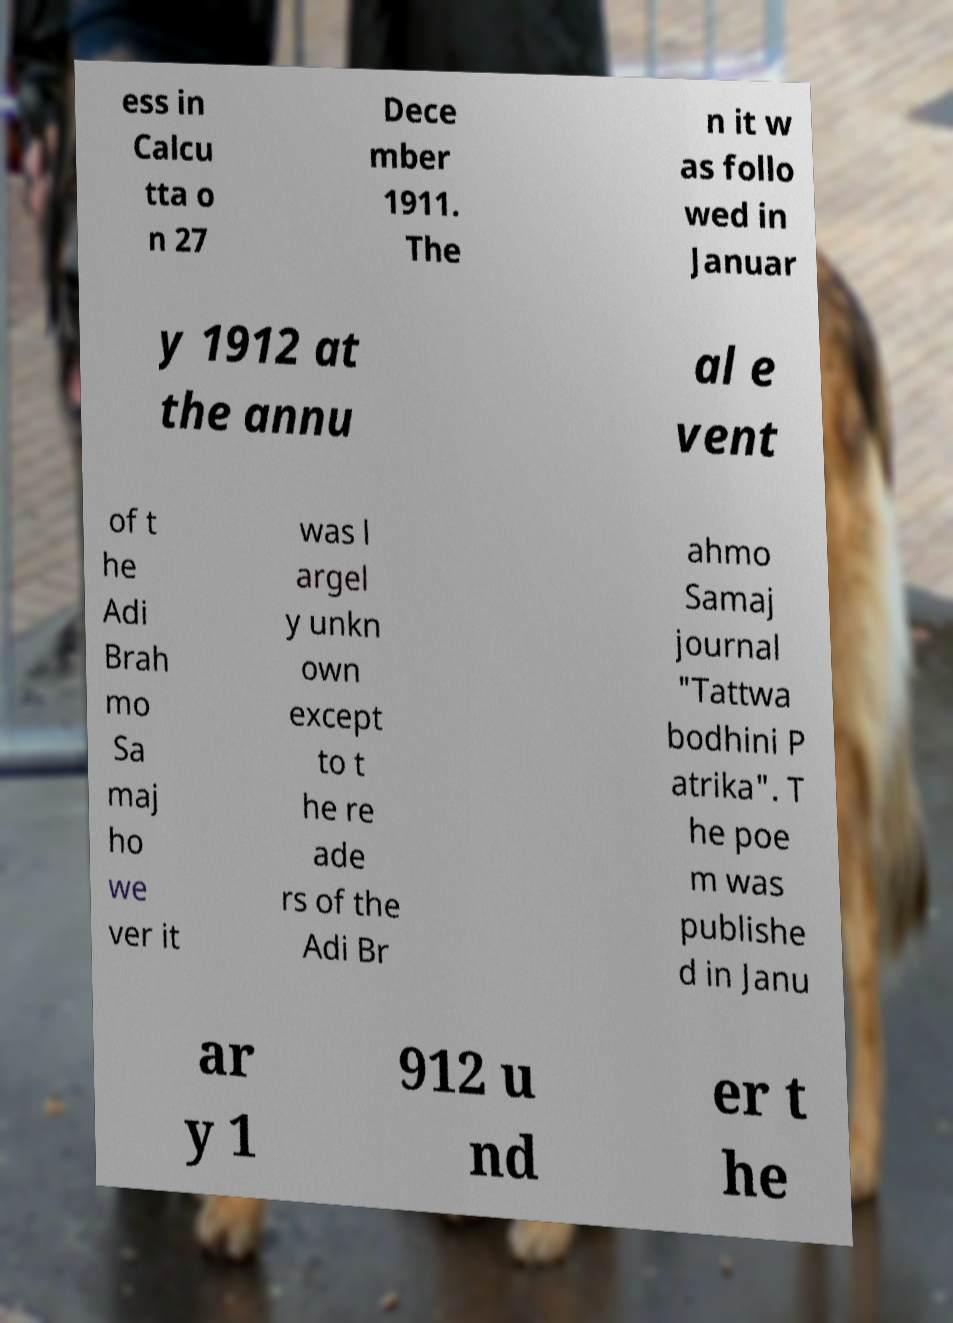Please read and relay the text visible in this image. What does it say? ess in Calcu tta o n 27 Dece mber 1911. The n it w as follo wed in Januar y 1912 at the annu al e vent of t he Adi Brah mo Sa maj ho we ver it was l argel y unkn own except to t he re ade rs of the Adi Br ahmo Samaj journal "Tattwa bodhini P atrika". T he poe m was publishe d in Janu ar y 1 912 u nd er t he 